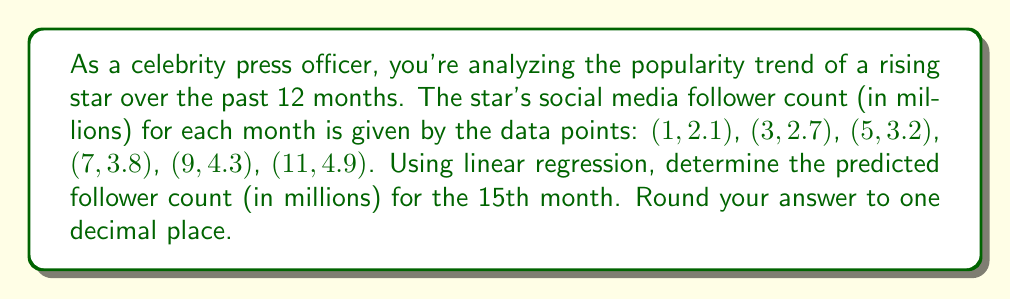Solve this math problem. To solve this problem using linear regression, we'll follow these steps:

1. Calculate the means of x (months) and y (follower count):
   $\bar{x} = \frac{1 + 3 + 5 + 7 + 9 + 11}{6} = 6$
   $\bar{y} = \frac{2.1 + 2.7 + 3.2 + 3.8 + 4.3 + 4.9}{6} = 3.5$

2. Calculate the slope (m) using the formula:
   $$m = \frac{\sum(x_i - \bar{x})(y_i - \bar{y})}{\sum(x_i - \bar{x})^2}$$

   $\sum(x_i - \bar{x})(y_i - \bar{y}) = (-5)(-1.4) + (-3)(-0.8) + (-1)(-0.3) + (1)(0.3) + (3)(0.8) + (5)(1.4) = 14$
   $\sum(x_i - \bar{x})^2 = (-5)^2 + (-3)^2 + (-1)^2 + (1)^2 + (3)^2 + (5)^2 = 70$

   $m = \frac{14}{70} = 0.2$

3. Calculate the y-intercept (b) using the formula:
   $b = \bar{y} - m\bar{x}$
   $b = 3.5 - 0.2(6) = 2.3$

4. The linear regression equation is:
   $y = mx + b = 0.2x + 2.3$

5. To predict the follower count for the 15th month, substitute x = 15:
   $y = 0.2(15) + 2.3 = 3 + 2.3 = 5.3$

Therefore, the predicted follower count for the 15th month is 5.3 million.
Answer: 5.3 million followers 